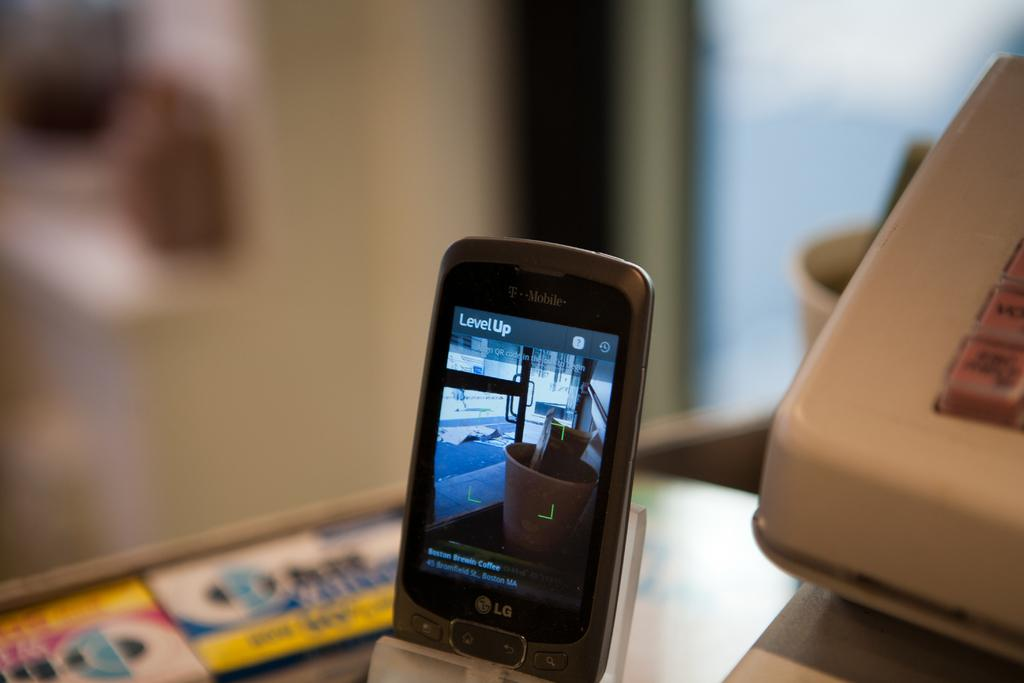<image>
Present a compact description of the photo's key features. A phone screen shows the words level up on the top. 